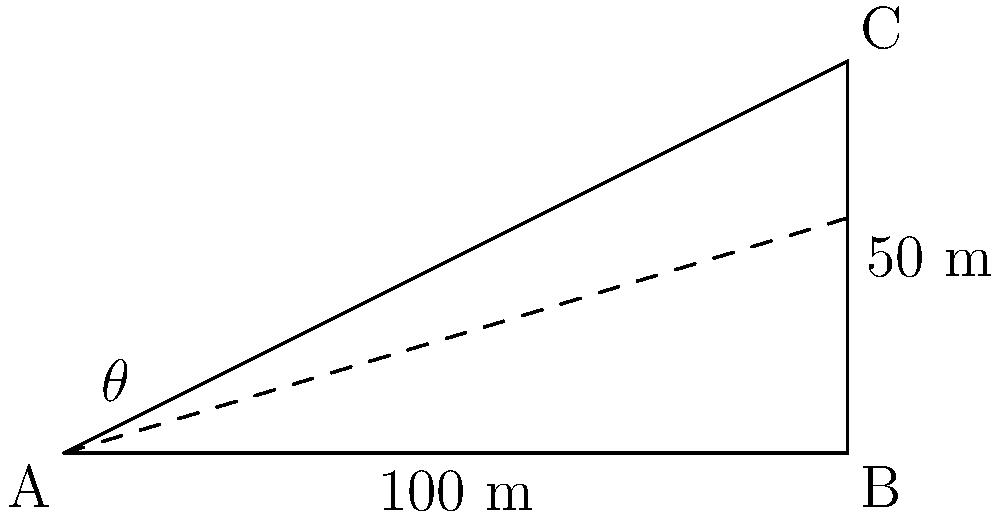At a scenic lookout point in the Bunya Mountains, you need to calculate the angle of inclination for a new viewing platform. The platform will be situated 100 meters horizontally from the base of the lookout and 50 meters above ground level. What is the angle of inclination ($\theta$) for the platform in degrees? To solve this problem, we can use basic trigonometry:

1. We have a right-angled triangle with the following measurements:
   - Adjacent side (horizontal distance) = 100 meters
   - Opposite side (vertical height) = 50 meters

2. To find the angle of inclination ($\theta$), we can use the tangent function:

   $\tan(\theta) = \frac{\text{opposite}}{\text{adjacent}}$

3. Substituting our values:

   $\tan(\theta) = \frac{50}{100} = 0.5$

4. To find $\theta$, we need to use the inverse tangent (arctan or $\tan^{-1}$):

   $\theta = \tan^{-1}(0.5)$

5. Using a calculator or trigonometric tables:

   $\theta \approx 26.57°$

6. Round to the nearest tenth of a degree:

   $\theta \approx 26.6°$
Answer: $26.6°$ 